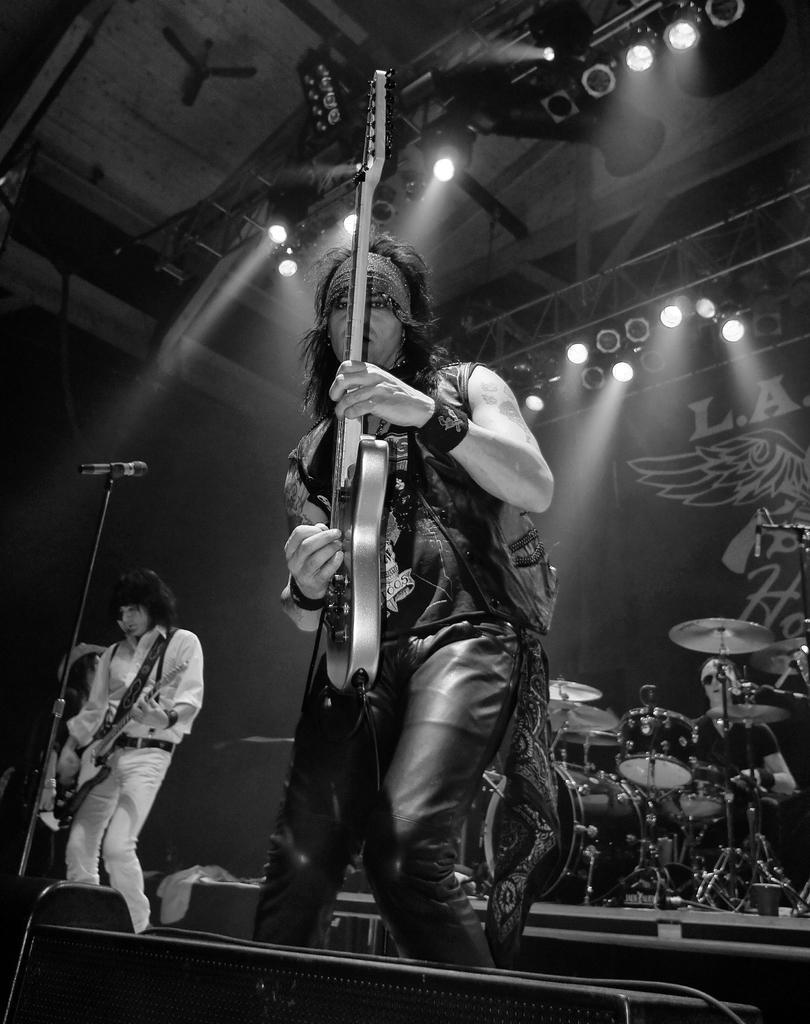Could you give a brief overview of what you see in this image? In the center of the image we can see two people standing and playing guitars. On the left there is a mic placed on the stand. In the background there is a band and we can see a man sitting and playing a band. At the top there are lights and a fan. 